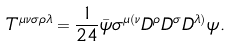Convert formula to latex. <formula><loc_0><loc_0><loc_500><loc_500>T ^ { \mu \nu \sigma \rho \lambda } = \frac { 1 } { 2 4 } \bar { \psi } \sigma ^ { \mu ( \nu } D ^ { \rho } D ^ { \sigma } D ^ { \lambda ) } \psi .</formula> 